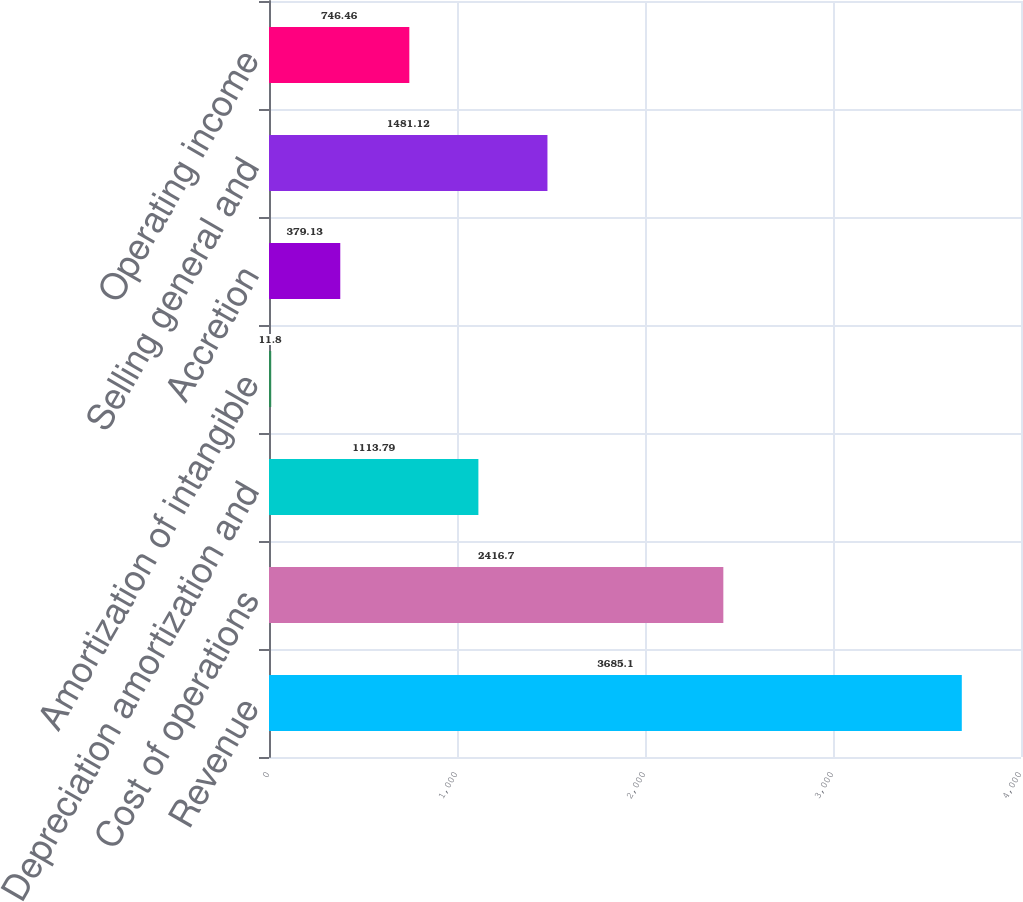Convert chart. <chart><loc_0><loc_0><loc_500><loc_500><bar_chart><fcel>Revenue<fcel>Cost of operations<fcel>Depreciation amortization and<fcel>Amortization of intangible<fcel>Accretion<fcel>Selling general and<fcel>Operating income<nl><fcel>3685.1<fcel>2416.7<fcel>1113.79<fcel>11.8<fcel>379.13<fcel>1481.12<fcel>746.46<nl></chart> 